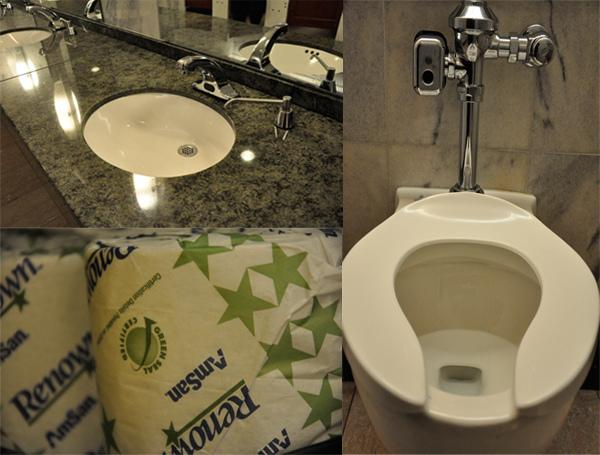How is the toilet flushed? automatic 